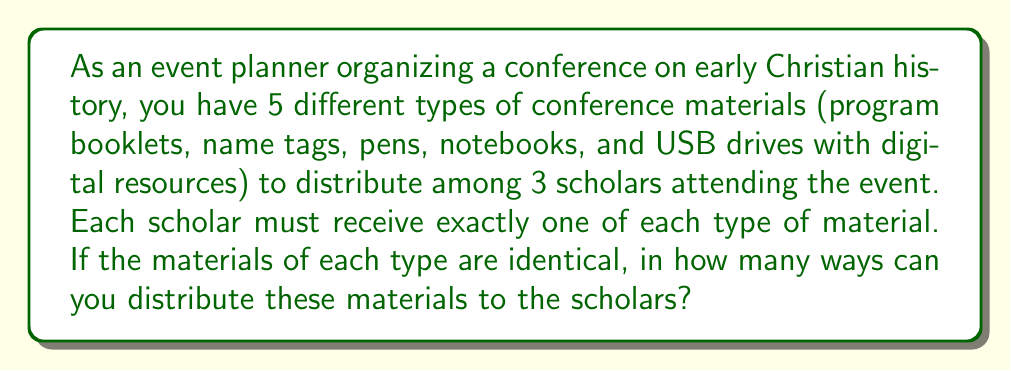Show me your answer to this math problem. Let's approach this step-by-step:

1) We have 5 types of materials, and each type needs to be distributed to 3 scholars.

2) For each type of material, we need to consider how many ways we can distribute it to the 3 scholars.

3) Since the materials of each type are identical, the distribution of each type is equivalent to choosing 3 scholars from 3, which can be done in only one way.

4) Mathematically, this is represented as:

   $$\binom{3}{3} = 1$$

5) We need to do this for each of the 5 types of materials independently.

6) According to the multiplication principle, if we have a series of independent choices, we multiply the number of ways for each choice to get the total number of ways for all choices.

7) Therefore, the total number of ways to distribute the materials is:

   $$1 \times 1 \times 1 \times 1 \times 1 = 1$$

This means there is only one way to distribute the materials, as the distribution of identical items among a fixed number of recipients doesn't allow for variation.
Answer: 1 way 